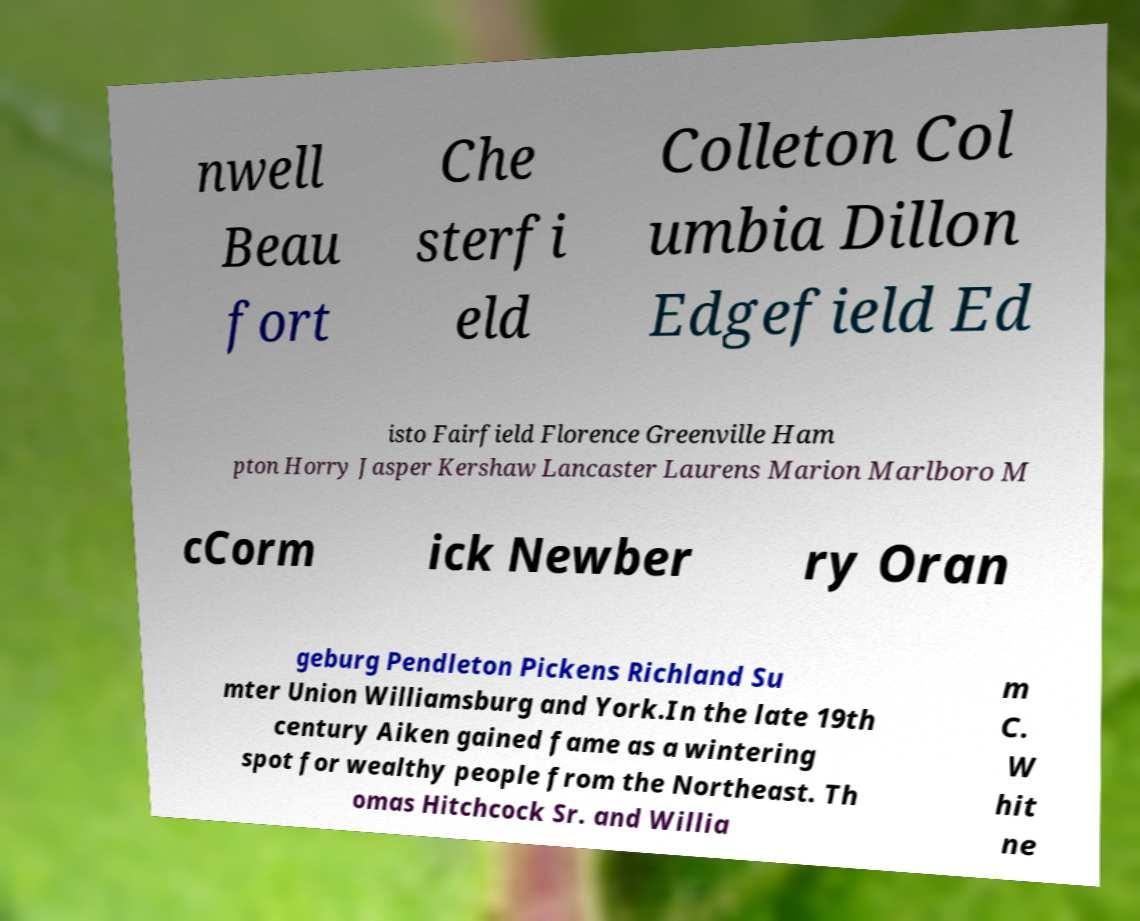Please identify and transcribe the text found in this image. nwell Beau fort Che sterfi eld Colleton Col umbia Dillon Edgefield Ed isto Fairfield Florence Greenville Ham pton Horry Jasper Kershaw Lancaster Laurens Marion Marlboro M cCorm ick Newber ry Oran geburg Pendleton Pickens Richland Su mter Union Williamsburg and York.In the late 19th century Aiken gained fame as a wintering spot for wealthy people from the Northeast. Th omas Hitchcock Sr. and Willia m C. W hit ne 